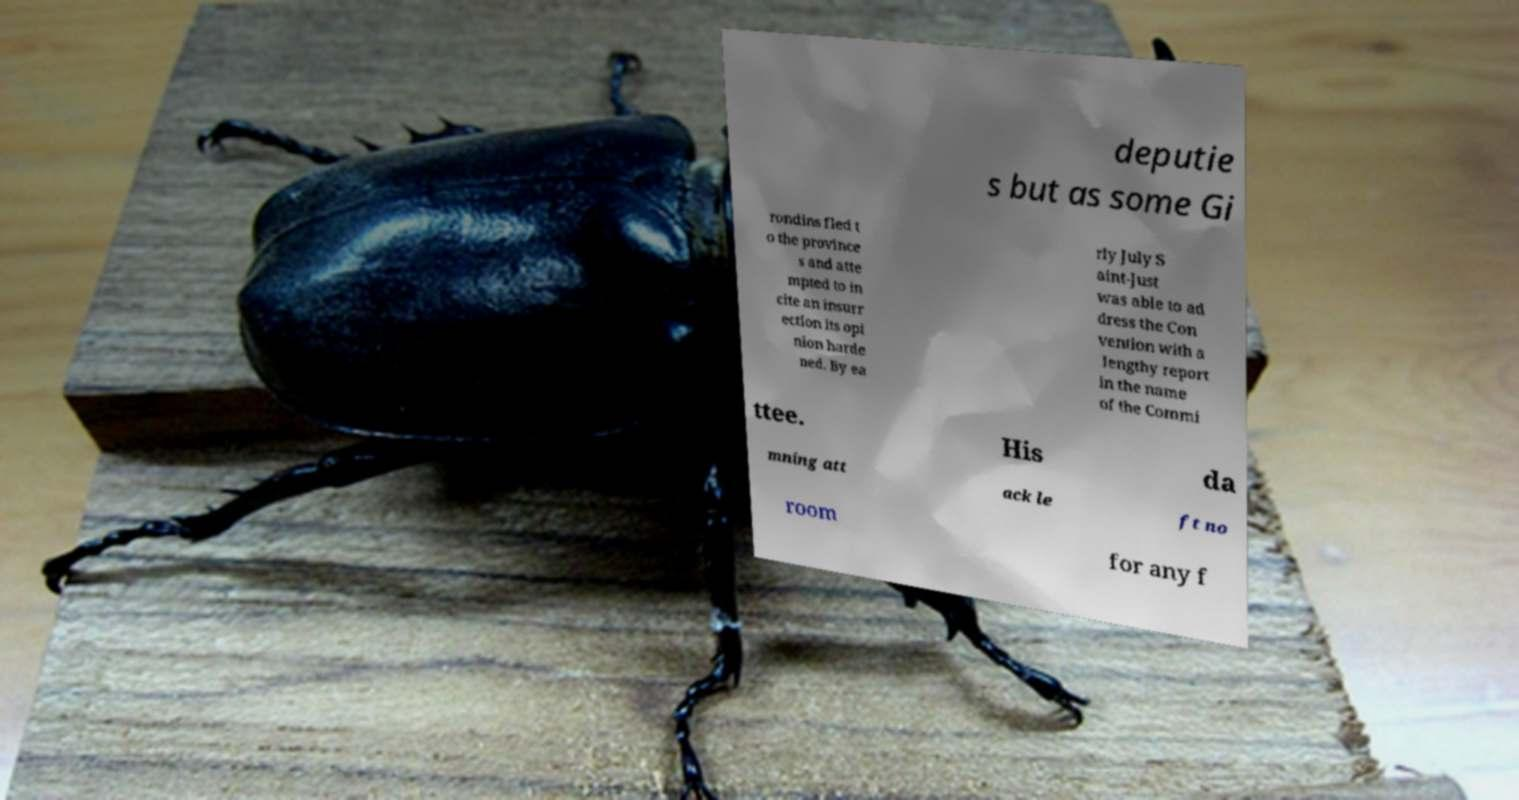For documentation purposes, I need the text within this image transcribed. Could you provide that? deputie s but as some Gi rondins fled t o the province s and atte mpted to in cite an insurr ection its opi nion harde ned. By ea rly July S aint-Just was able to ad dress the Con vention with a lengthy report in the name of the Commi ttee. His da mning att ack le ft no room for any f 